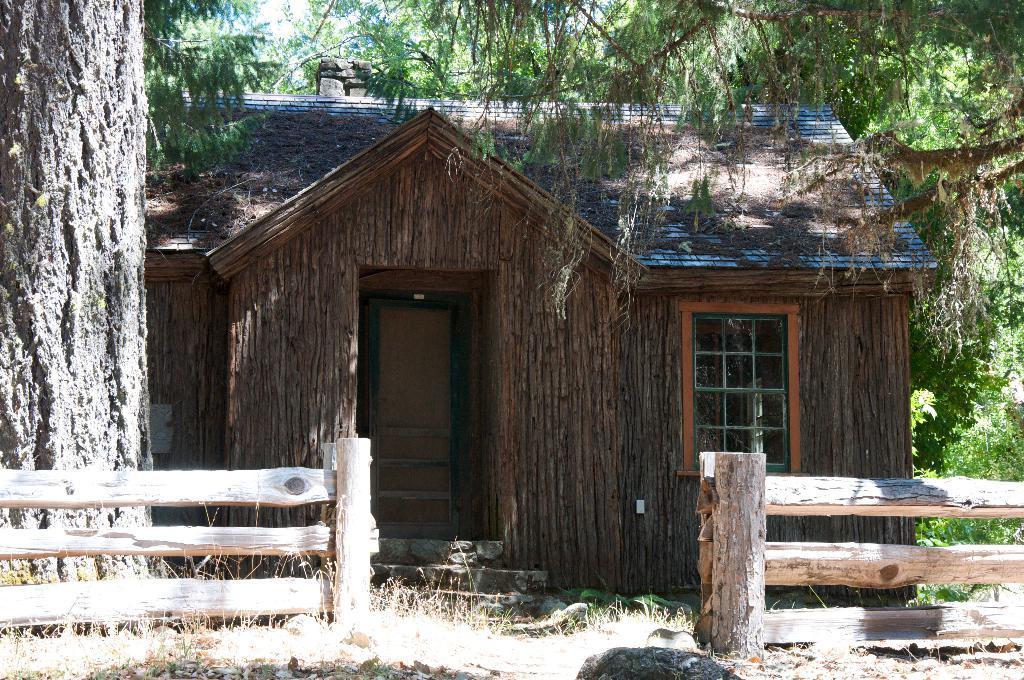Can you describe this image briefly? In this picture we can see a shed with a door, window and in front of this shed we can see wooden fence, tree trunk and some objects and in the background we can see trees. 